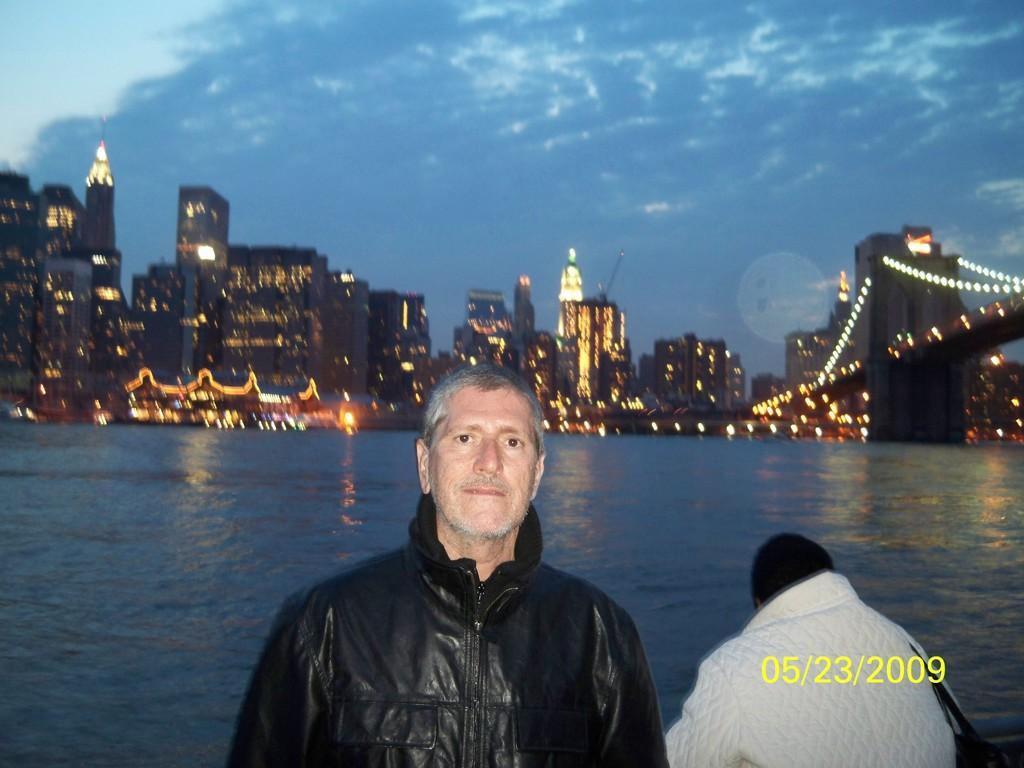Please provide a concise description of this image. In this image we can see two persons and date on the image. In the background we can see water, buildings, decorative lights, bridge and clouds in the sky. 